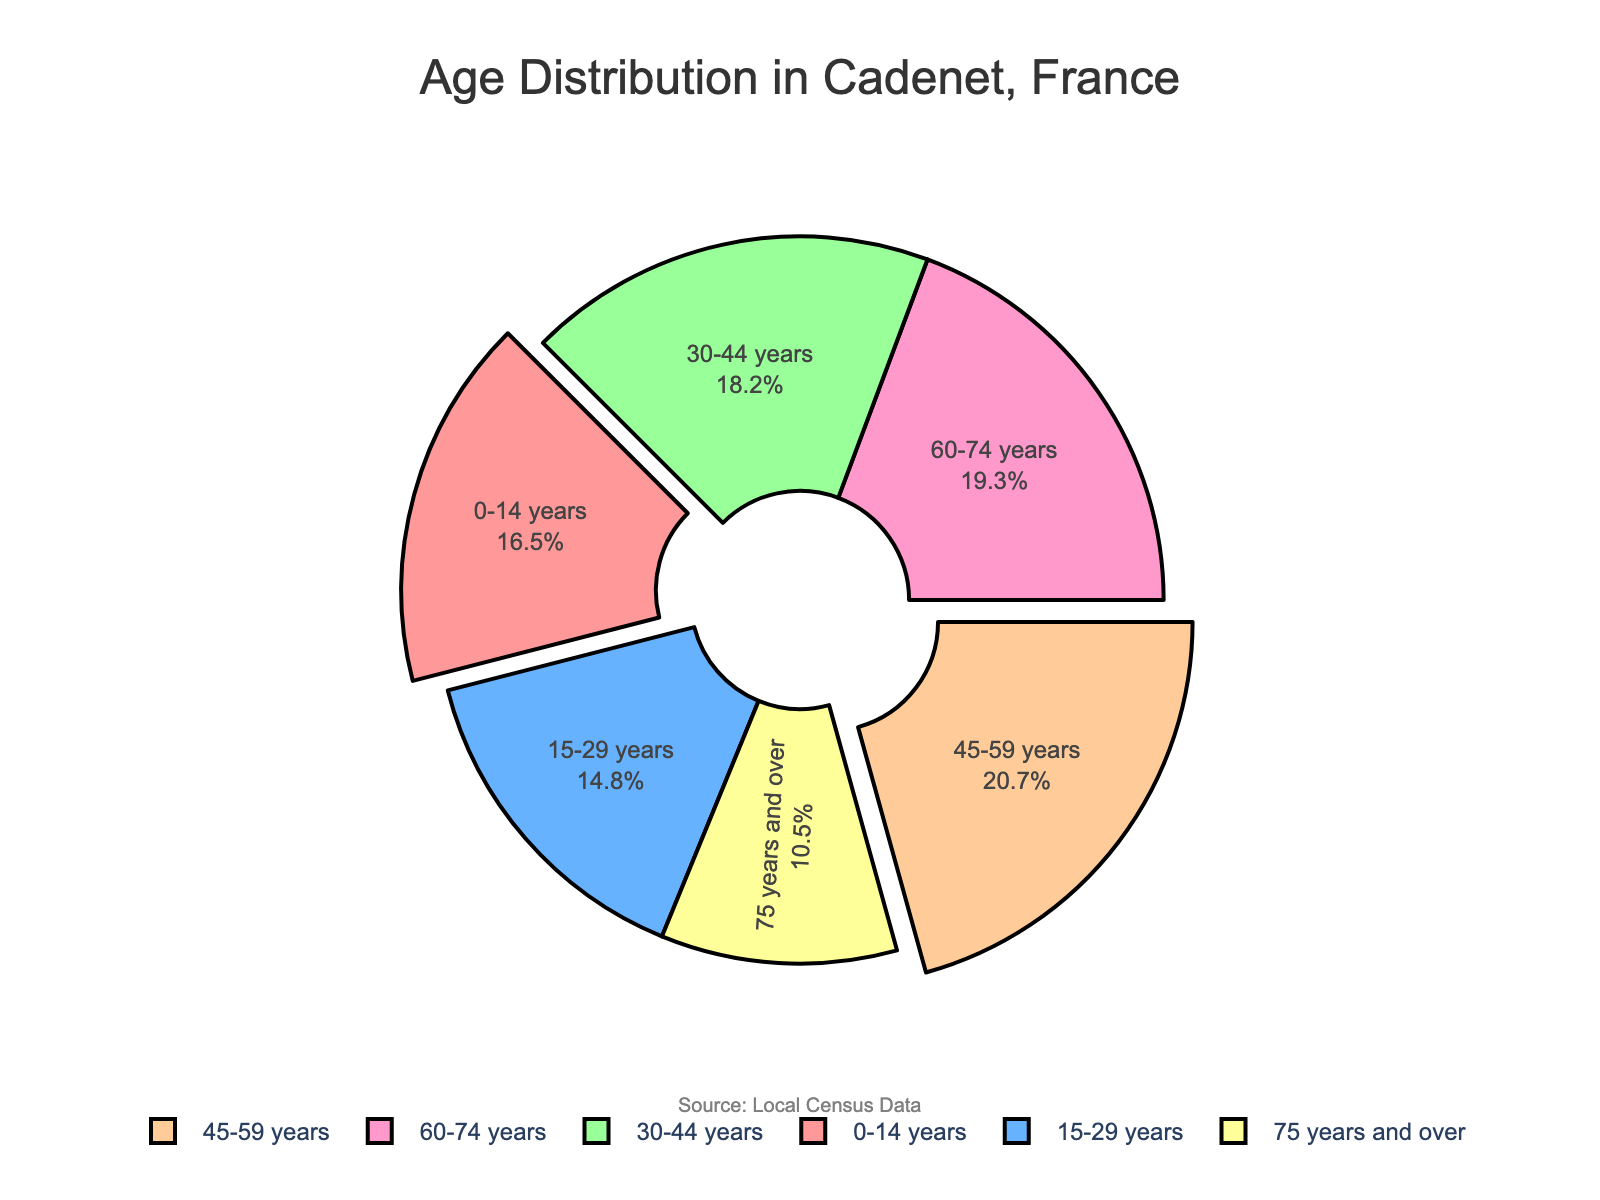Which age group has the highest percentage in Cadenet's population? The slice for the 45-59 years age group is the largest in the pie chart, indicating that this category has the highest percentage.
Answer: 45-59 years Which two age groups have their segments pulled out from the pie chart? The segments for the 0-14 years and 45-59 years groups are slightly pulled out from the pie chart, making them visually distinct.
Answer: 0-14 years, 45-59 years How many age groups have a percentage that is greater than or equal to 18%? There are three segments with a percentage of 18% or greater: 30-44 years (18.2%), 45-59 years (20.7%), and 60-74 years (19.3%).
Answer: 3 What is the combined percentage of the youngest (0-14 years) and oldest (75 years and over) age groups? Adding the percentages of 0-14 years (16.5%) and 75 years and over (10.5%) gives a combined percentage of 27%. 16.5% + 10.5% = 27%
Answer: 27% Is the percentage of the 15-29 years age group greater or less than the percentage of the 60-74 years age group? The 15-29 years group has 14.8%, which is less than the 19.3% of the 60-74 years group.
Answer: Less Which age group makes up the smallest portion of Cadenet's population? The smallest segment in the pie chart belongs to the 75 years and over age group, indicating it has the lowest percentage.
Answer: 75 years and over What is the difference in percentage between the 30-44 years and 60-74 years age groups? Subtract the percentage of the 30-44 years group (18.2%) from the 60-74 years group (19.3%) to get the difference. 19.3% - 18.2% = 1.1%
Answer: 1.1% How does the percentage of the 0-14 years age group compare to the combined percentage of the 15-29 years and 75 years and over age groups? The combined percentage of 15-29 years (14.8%) and 75 years and over (10.5%) is 25.3%. The 0-14 years group is 16.5%, which is less.
Answer: Less What is the combined percentage of the middle age groups (30-44 years and 45-59 years)? Adding the percentages of 30-44 years (18.2%) and 45-59 years (20.7%) gives a combined percentage of 38.9%. 18.2% + 20.7% = 38.9%
Answer: 38.9% Which age group is represented by the color blue? The segment colored in blue corresponds to the 15-29 years age group.
Answer: 15-29 years 